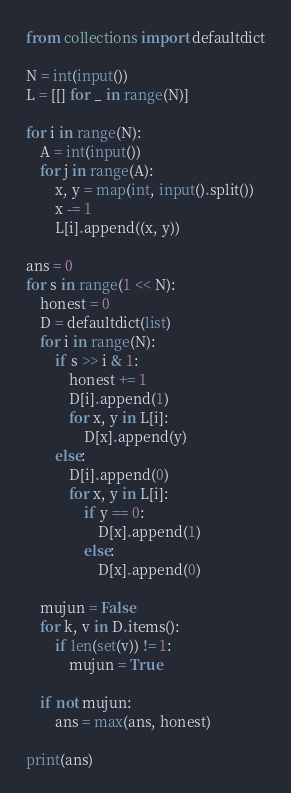Convert code to text. <code><loc_0><loc_0><loc_500><loc_500><_Python_>from collections import defaultdict

N = int(input())
L = [[] for _ in range(N)]

for i in range(N):
    A = int(input())
    for j in range(A):
        x, y = map(int, input().split())
        x -= 1
        L[i].append((x, y))

ans = 0
for s in range(1 << N):
    honest = 0
    D = defaultdict(list)
    for i in range(N):
        if s >> i & 1:
            honest += 1
            D[i].append(1)
            for x, y in L[i]:
                D[x].append(y)
        else:
            D[i].append(0)
            for x, y in L[i]:
                if y == 0:
                    D[x].append(1)
                else:
                    D[x].append(0)

    mujun = False
    for k, v in D.items():
        if len(set(v)) != 1:
            mujun = True

    if not mujun:
        ans = max(ans, honest)

print(ans)
</code> 